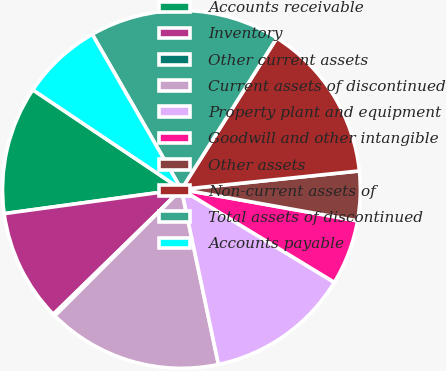<chart> <loc_0><loc_0><loc_500><loc_500><pie_chart><fcel>Accounts receivable<fcel>Inventory<fcel>Other current assets<fcel>Current assets of discontinued<fcel>Property plant and equipment<fcel>Goodwill and other intangible<fcel>Other assets<fcel>Non-current assets of<fcel>Total assets of discontinued<fcel>Accounts payable<nl><fcel>11.56%<fcel>10.14%<fcel>0.19%<fcel>15.83%<fcel>12.99%<fcel>5.88%<fcel>4.46%<fcel>14.41%<fcel>17.25%<fcel>7.3%<nl></chart> 